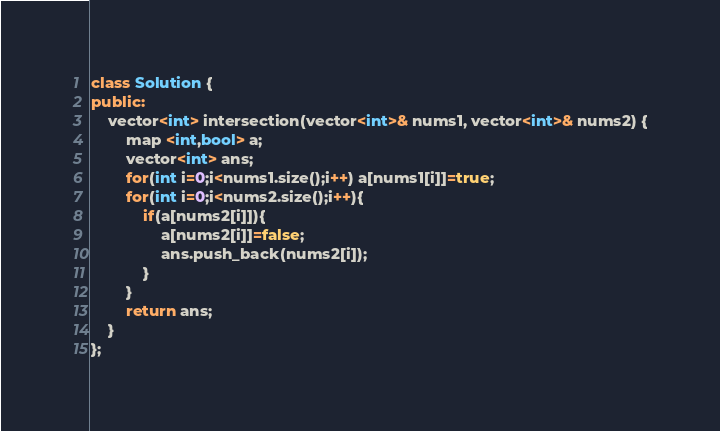Convert code to text. <code><loc_0><loc_0><loc_500><loc_500><_C++_>class Solution {
public:
    vector<int> intersection(vector<int>& nums1, vector<int>& nums2) {
        map <int,bool> a;
        vector<int> ans;
        for(int i=0;i<nums1.size();i++) a[nums1[i]]=true;
        for(int i=0;i<nums2.size();i++){
            if(a[nums2[i]]){
                a[nums2[i]]=false;
                ans.push_back(nums2[i]);
            }
        }
        return ans;
    } 
};
</code> 